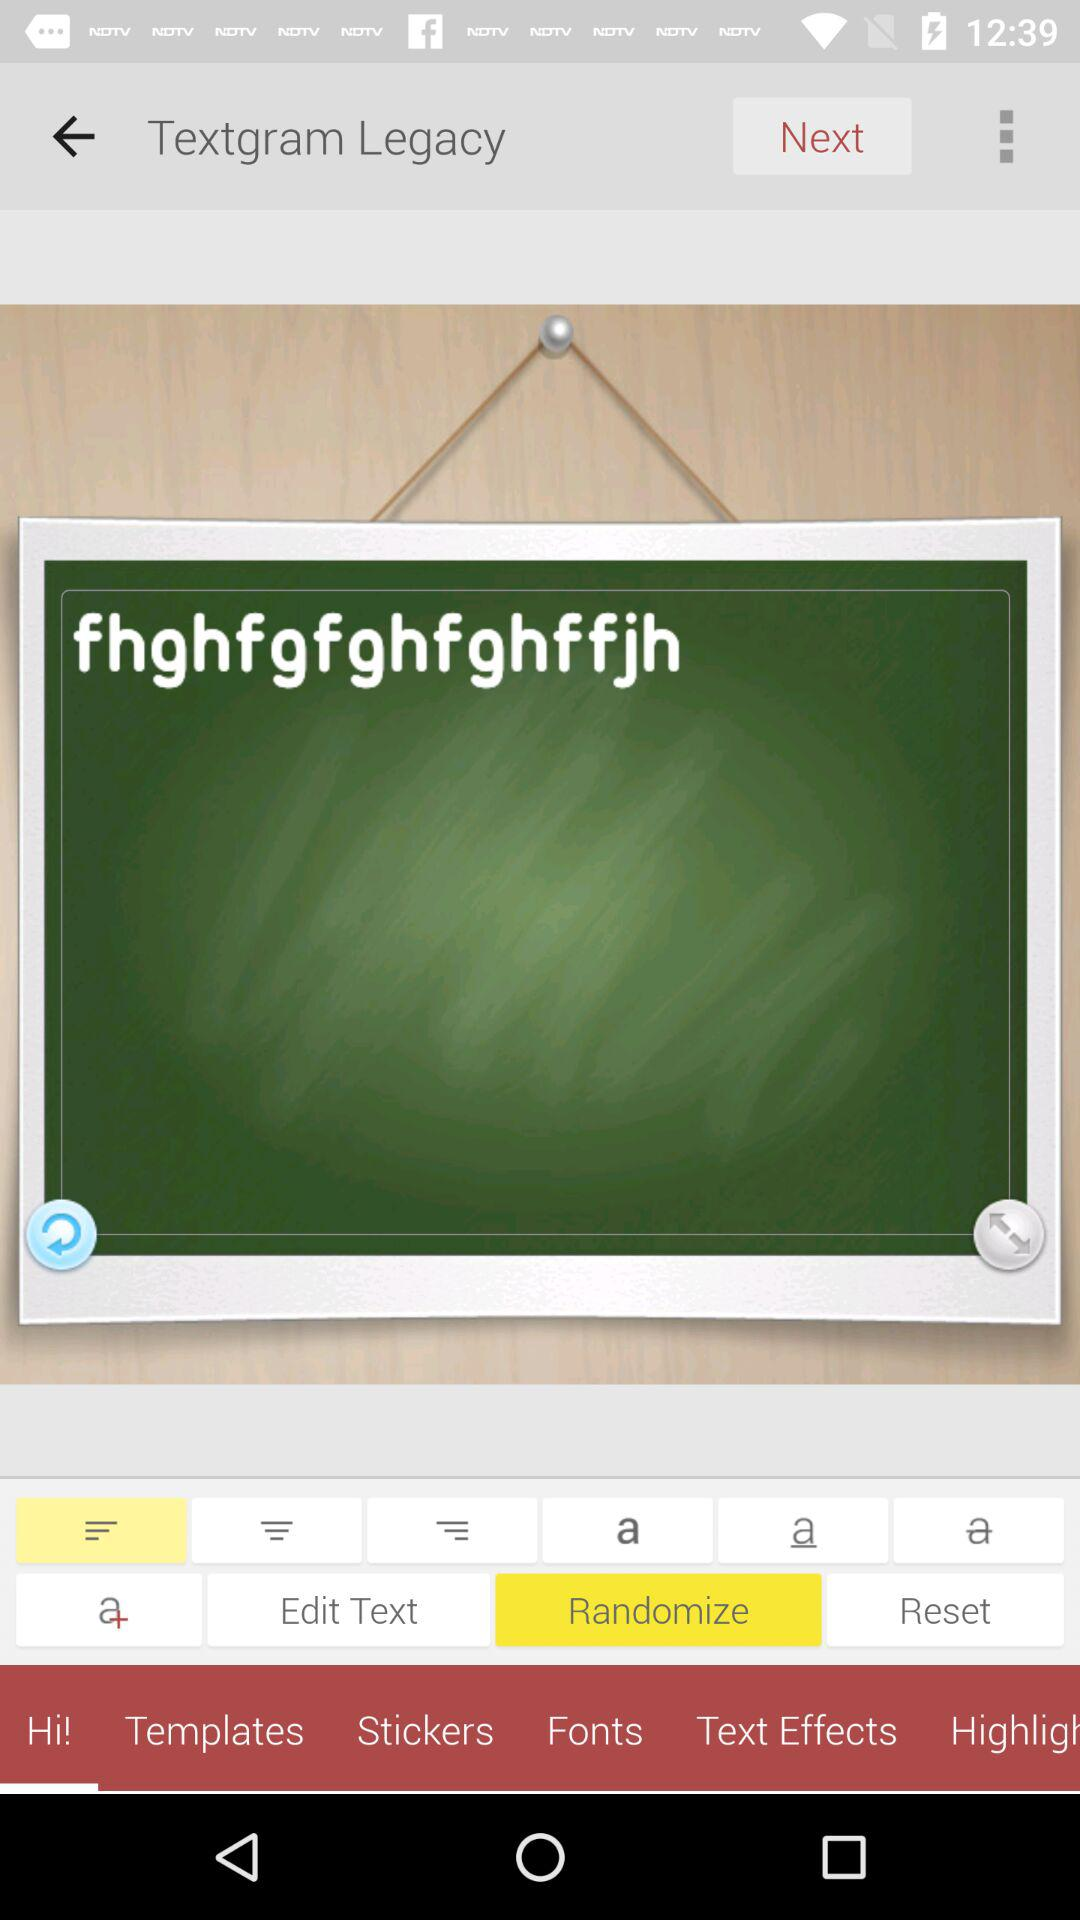Which button is selected? The selected buttons are "Align Left" and "Randomize". 